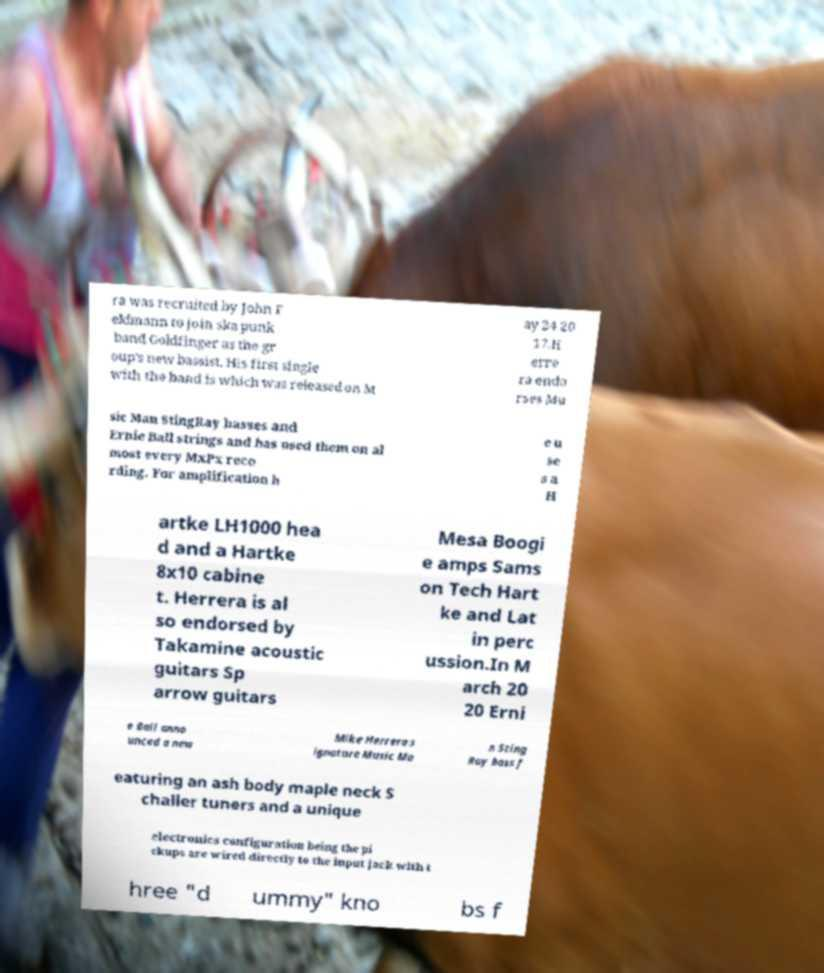Can you read and provide the text displayed in the image?This photo seems to have some interesting text. Can you extract and type it out for me? ra was recruited by John F eldmann to join ska punk band Goldfinger as the gr oup's new bassist. His first single with the band is which was released on M ay 24 20 17.H erre ra endo rses Mu sic Man StingRay basses and Ernie Ball strings and has used them on al most every MxPx reco rding. For amplification h e u se s a H artke LH1000 hea d and a Hartke 8x10 cabine t. Herrera is al so endorsed by Takamine acoustic guitars Sp arrow guitars Mesa Boogi e amps Sams on Tech Hart ke and Lat in perc ussion.In M arch 20 20 Erni e Ball anno unced a new Mike Herrera s ignature Music Ma n Sting Ray bass f eaturing an ash body maple neck S challer tuners and a unique electronics configuration being the pi ckups are wired directly to the input jack with t hree "d ummy" kno bs f 